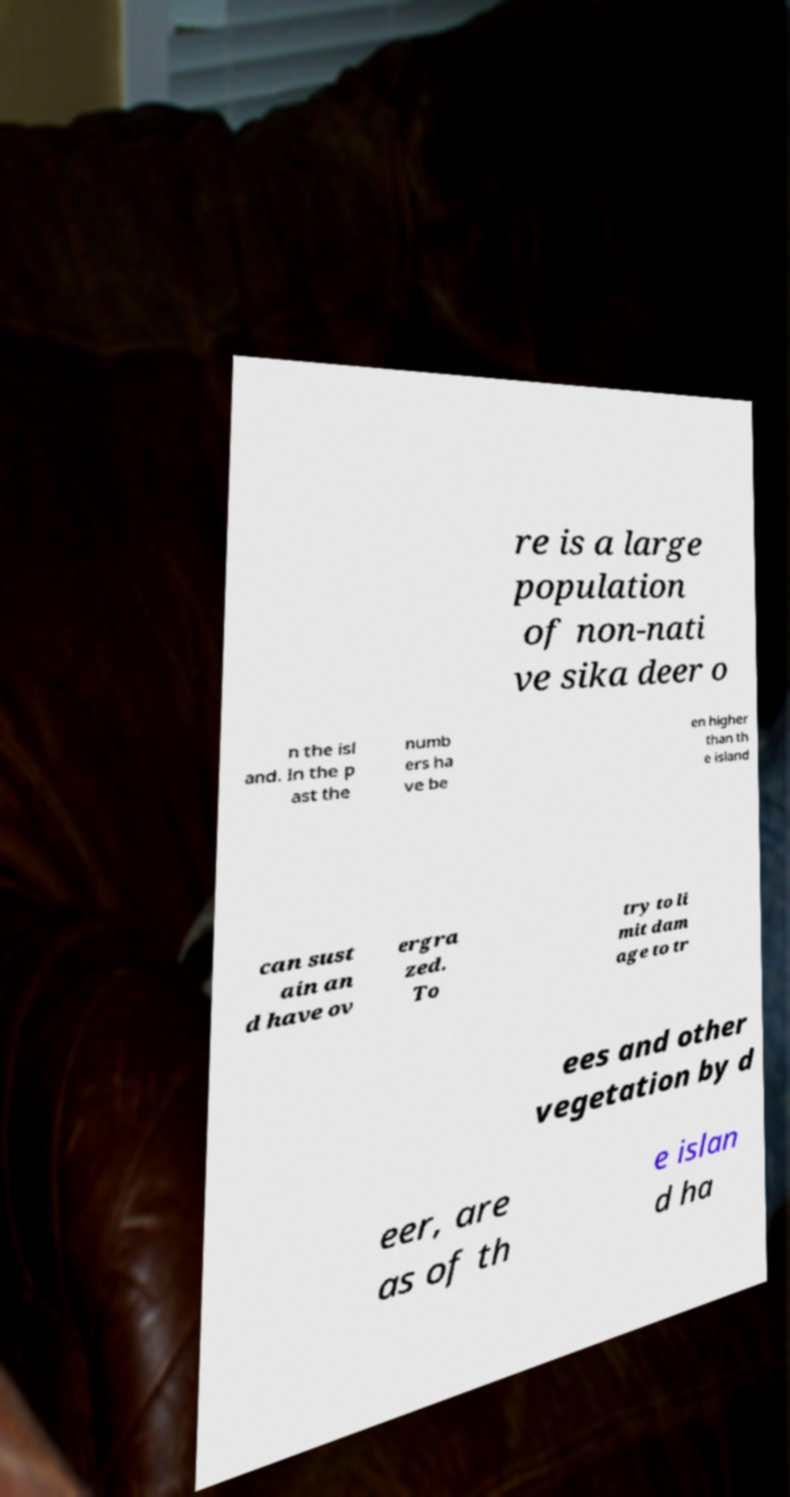What messages or text are displayed in this image? I need them in a readable, typed format. re is a large population of non-nati ve sika deer o n the isl and. In the p ast the numb ers ha ve be en higher than th e island can sust ain an d have ov ergra zed. To try to li mit dam age to tr ees and other vegetation by d eer, are as of th e islan d ha 